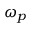<formula> <loc_0><loc_0><loc_500><loc_500>\omega _ { p }</formula> 